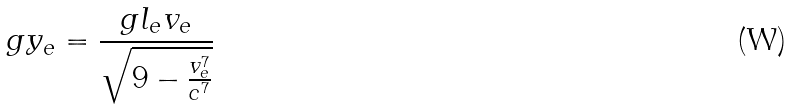<formula> <loc_0><loc_0><loc_500><loc_500>g y _ { e } = \frac { g l _ { e } v _ { e } } { \sqrt { 9 - \frac { v _ { e } ^ { 7 } } { c ^ { 7 } } } }</formula> 